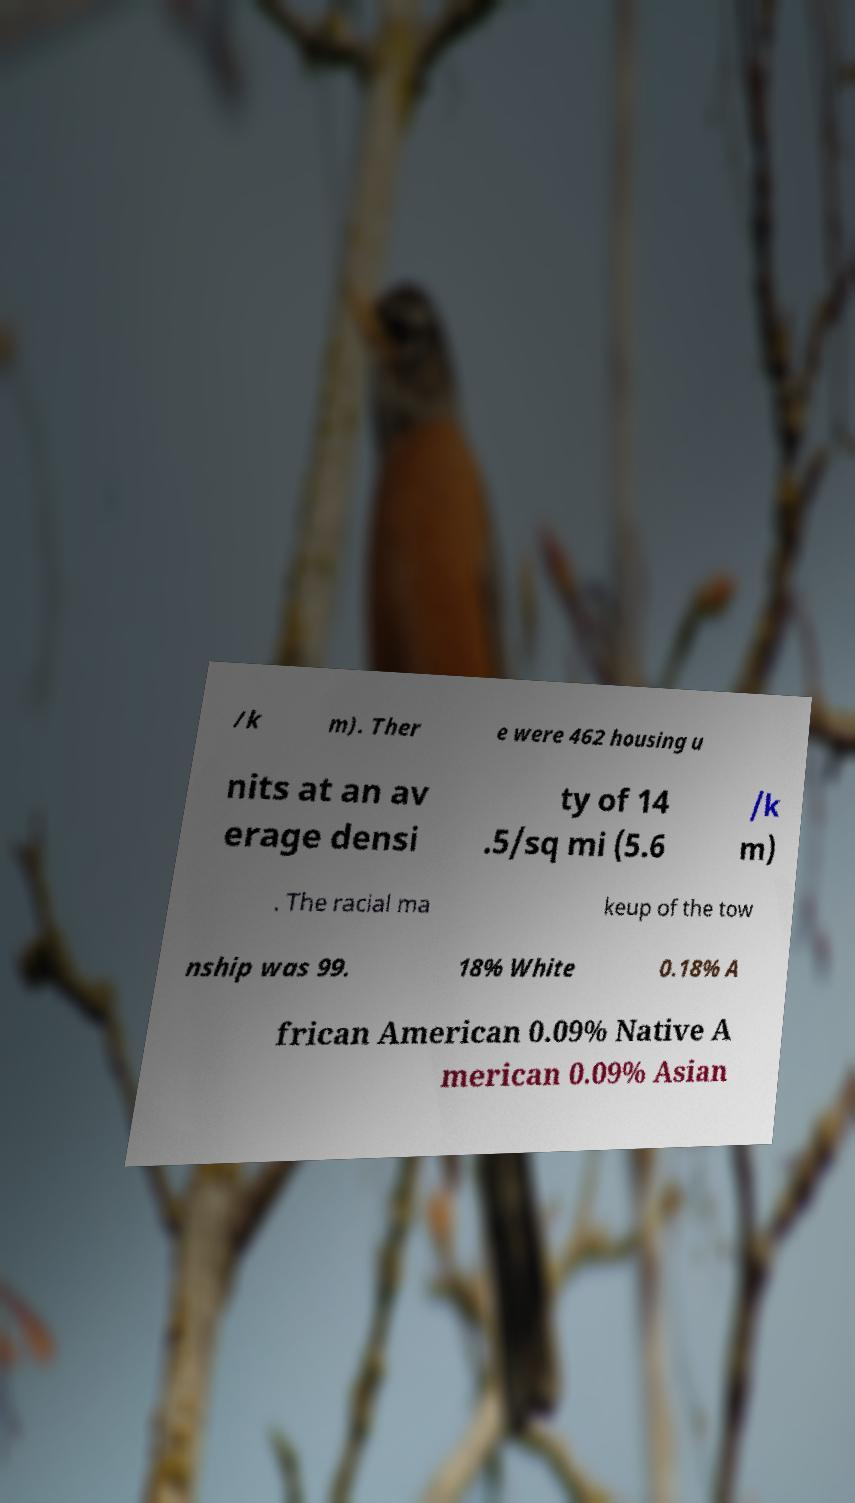Could you extract and type out the text from this image? /k m). Ther e were 462 housing u nits at an av erage densi ty of 14 .5/sq mi (5.6 /k m) . The racial ma keup of the tow nship was 99. 18% White 0.18% A frican American 0.09% Native A merican 0.09% Asian 